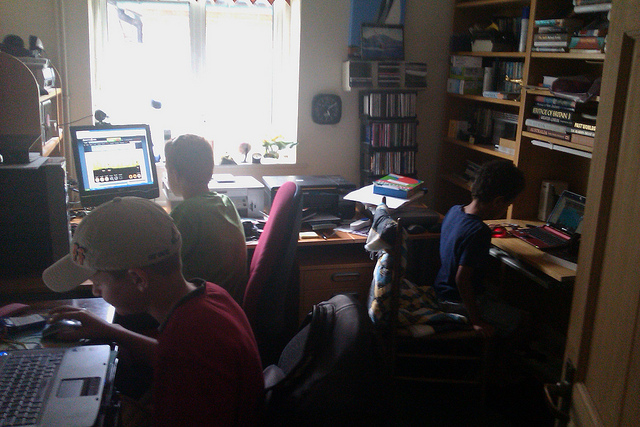<image>Where is the calendar located in this picture? It is unknown where the calendar is located in the picture. It might be on the wall or on the table. What is the photographer wearing? It is not visible what the photographer is wearing. Where is the calendar located in this picture? I don't know where the calendar is located in this picture. It can be on the wall, on the table or on the computer. What is the photographer wearing? I don't know what the photographer is wearing. It can be a shirt and a hat, or something else. 